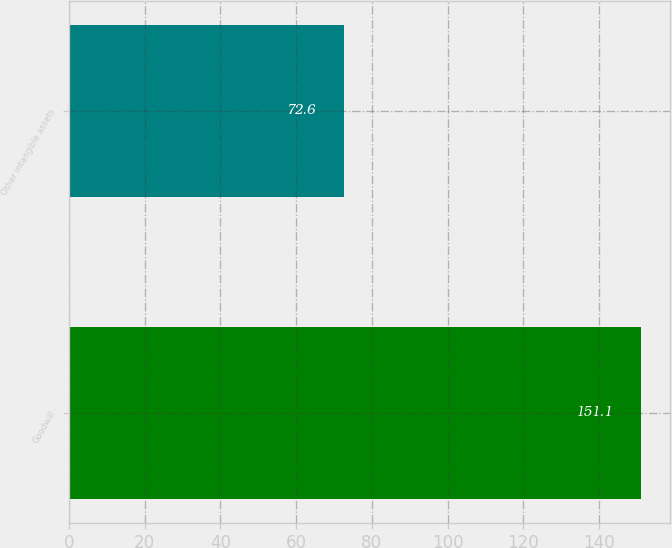<chart> <loc_0><loc_0><loc_500><loc_500><bar_chart><fcel>Goodwill<fcel>Other intangible assets<nl><fcel>151.1<fcel>72.6<nl></chart> 